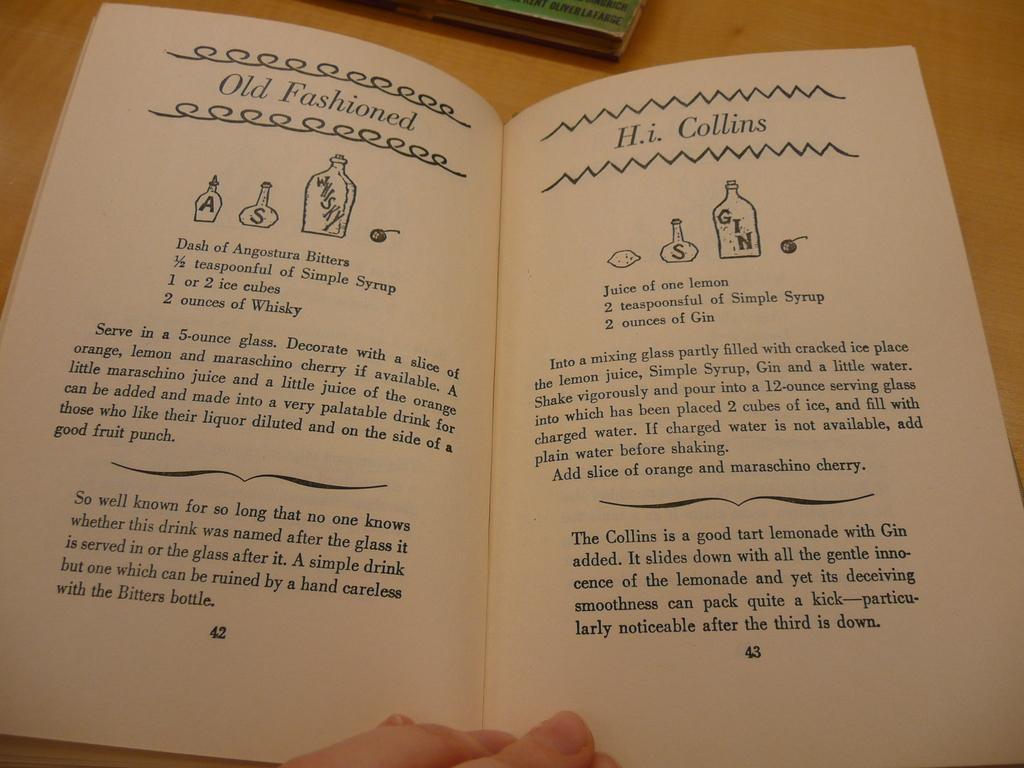<image>
Share a concise interpretation of the image provided. A person has opened a book to page 43 titled Old Fashioned. 